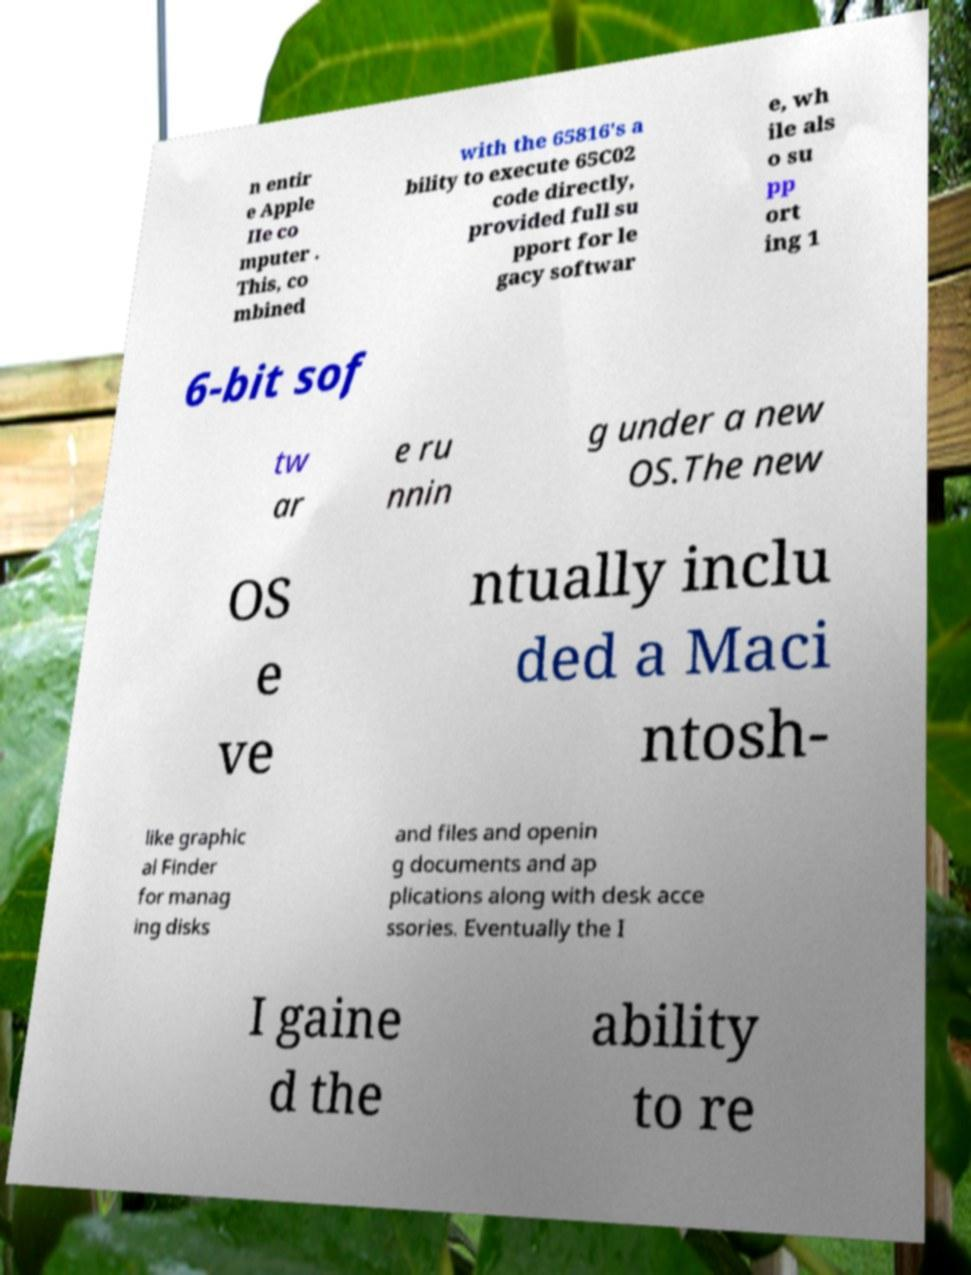For documentation purposes, I need the text within this image transcribed. Could you provide that? n entir e Apple IIe co mputer . This, co mbined with the 65816's a bility to execute 65C02 code directly, provided full su pport for le gacy softwar e, wh ile als o su pp ort ing 1 6-bit sof tw ar e ru nnin g under a new OS.The new OS e ve ntually inclu ded a Maci ntosh- like graphic al Finder for manag ing disks and files and openin g documents and ap plications along with desk acce ssories. Eventually the I I gaine d the ability to re 